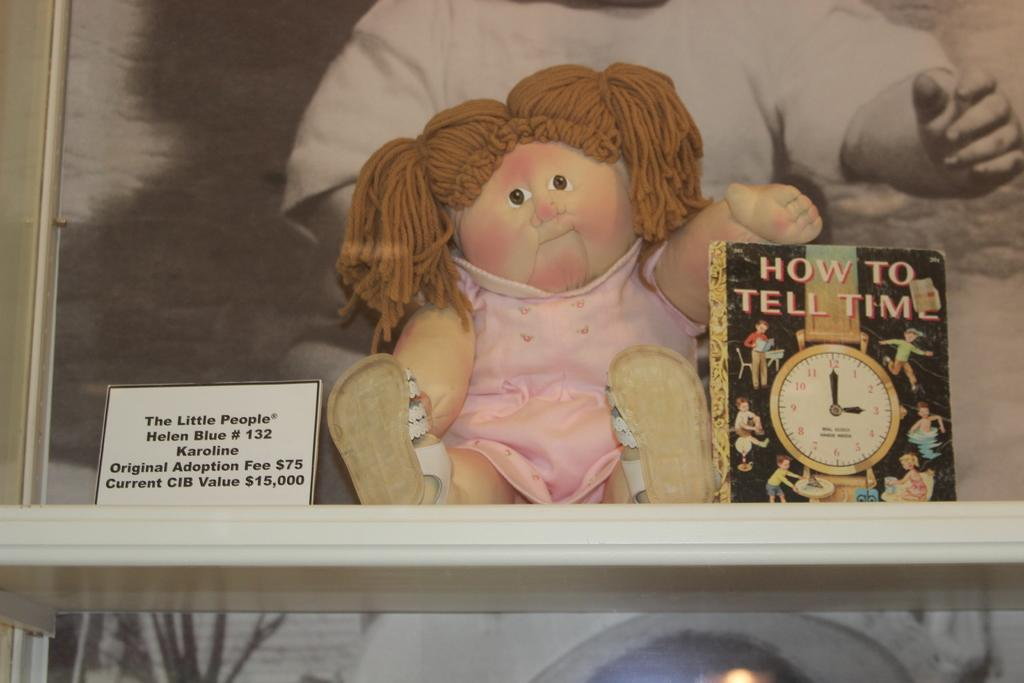<image>
Provide a brief description of the given image. A girl doll sits on a shelf holding the book "How To Tell Time". 